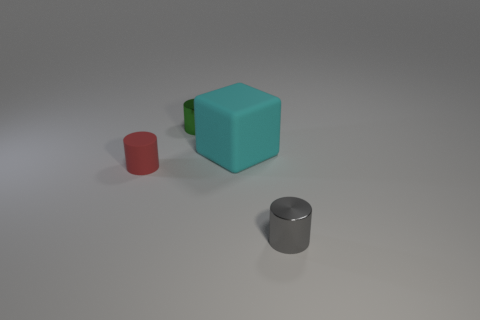Subtract all green shiny cylinders. How many cylinders are left? 2 Subtract all green cylinders. How many cylinders are left? 2 Subtract 1 cylinders. How many cylinders are left? 2 Add 1 tiny cylinders. How many objects exist? 5 Subtract all cyan cylinders. Subtract all red spheres. How many cylinders are left? 3 Subtract all purple cubes. How many red cylinders are left? 1 Subtract all tiny red rubber blocks. Subtract all green things. How many objects are left? 3 Add 2 tiny gray cylinders. How many tiny gray cylinders are left? 3 Add 1 cyan rubber blocks. How many cyan rubber blocks exist? 2 Subtract 1 green cylinders. How many objects are left? 3 